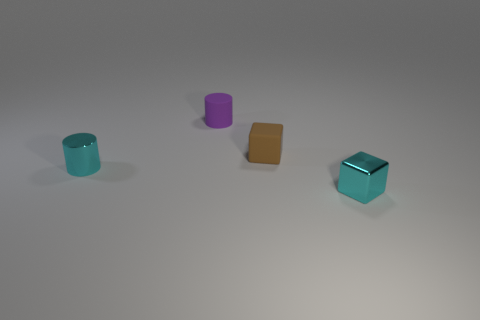Add 4 small metallic cylinders. How many objects exist? 8 Add 1 cyan shiny things. How many cyan shiny things exist? 3 Subtract 0 purple cubes. How many objects are left? 4 Subtract all tiny purple rubber things. Subtract all tiny metal blocks. How many objects are left? 2 Add 1 cyan cylinders. How many cyan cylinders are left? 2 